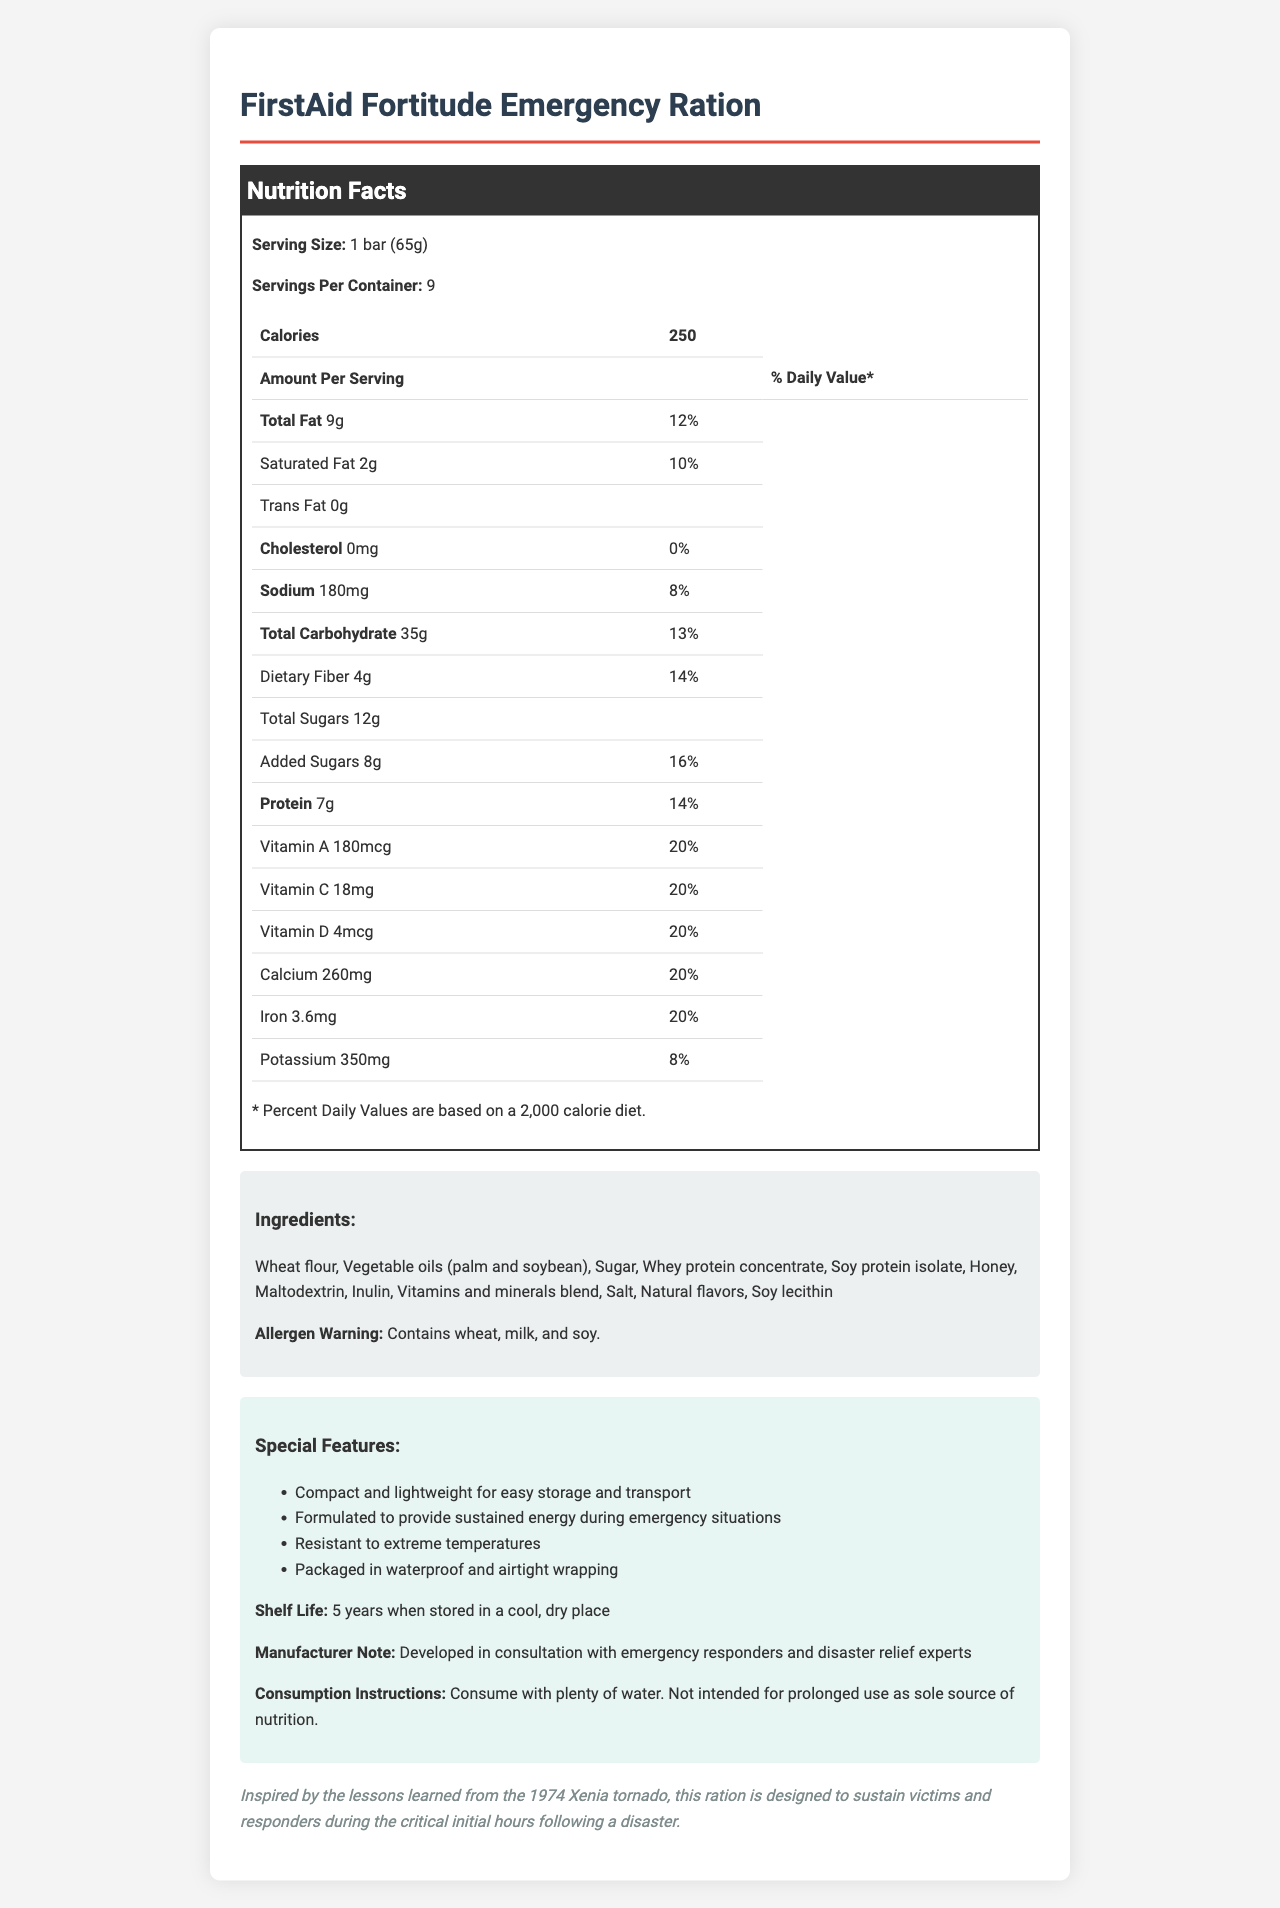what is the serving size of the FirstAid Fortitude Emergency Ration? The serving size is explicitly listed as "1 bar (65g)" in the nutrition facts section of the document.
Answer: 1 bar (65g) how many servings are in each container? The document states "Servings Per Container: 9" in the nutrition facts section.
Answer: 9 what is the total fat content per serving? Under the "Total Fat" section, it states "9g".
Answer: 9g what allergens are present in the FirstAid Fortitude Emergency Ration? The allergen warning section at the bottom lists "Contains wheat, milk, and soy."
Answer: Wheat, milk, and soy what is the shelf life of this emergency ration? This information is available in the "Special Features" section under the shelf life heading.
Answer: 5 years when stored in a cool, dry place what percentage of the daily value for Vitamin A does one serving provide? A. 10% B. 15% C. 20% D. 25% The nutrition facts table lists Vitamin A as providing 20% of the daily value per serving.
Answer: C. 20% which of the following ingredients is not included in the FirstAid Fortitude Emergency Ration? 1. Wheat flour 2. Vegetable oils 3. Almonds 4. Honey The ingredients list includes wheat flour, vegetable oils, and honey but not almonds.
Answer: 3. Almonds does this product contain any trans fat? The document lists "Trans Fat 0g," indicating no trans fat per serving.
Answer: No summarize what is covered in the document about the FirstAid Fortitude Emergency Ration. The summary includes all major sections covered, such as nutritional facts, ingredients, special features, shelf life, and the historical inspiration behind the product.
Answer: The document provides detailed nutritional information about the FirstAid Fortitude Emergency Ration, listing serving size, servings per container, calories, and percentages of daily values for various nutrients. It includes a comprehensive list of ingredients and allergen warnings. It highlights special features such as shelf life, compactness, and content durability, making it suitable for disaster preparedness scenarios. Specific consumption instructions are provided, and it references the lessons learned from the 1974 Xenia tornado as an inspiration for the product design. what was the calorie count for 2 bars of the emergency ration? The nutrition facts list calories per serving, but without the number of bars in a serving, we can't determine the total calories for two bars exactly.
Answer: Not enough information 